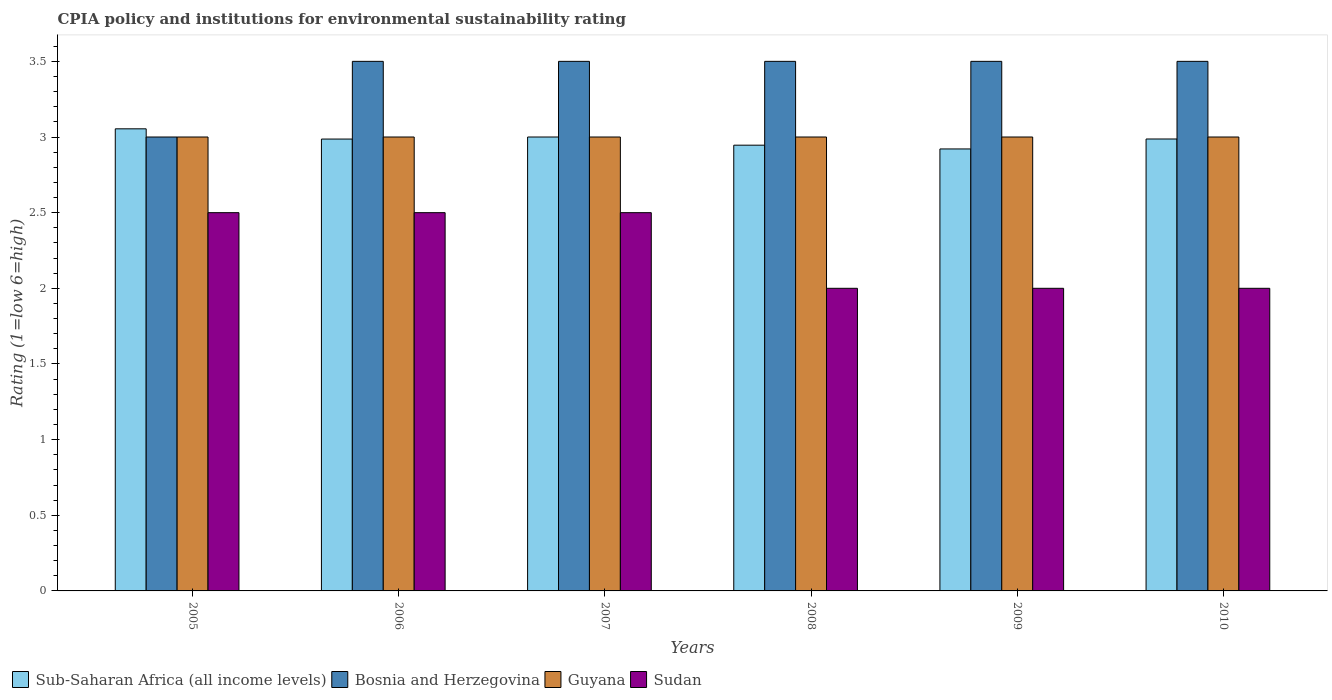How many groups of bars are there?
Make the answer very short. 6. Are the number of bars per tick equal to the number of legend labels?
Offer a terse response. Yes. Are the number of bars on each tick of the X-axis equal?
Your answer should be compact. Yes. How many bars are there on the 5th tick from the left?
Your answer should be compact. 4. How many bars are there on the 6th tick from the right?
Offer a terse response. 4. What is the CPIA rating in Sub-Saharan Africa (all income levels) in 2005?
Offer a terse response. 3.05. Across all years, what is the maximum CPIA rating in Sub-Saharan Africa (all income levels)?
Make the answer very short. 3.05. Across all years, what is the minimum CPIA rating in Bosnia and Herzegovina?
Provide a succinct answer. 3. What is the total CPIA rating in Guyana in the graph?
Offer a very short reply. 18. What is the difference between the CPIA rating in Guyana in 2009 and that in 2010?
Offer a very short reply. 0. What is the difference between the CPIA rating in Sub-Saharan Africa (all income levels) in 2008 and the CPIA rating in Sudan in 2010?
Provide a succinct answer. 0.95. What is the average CPIA rating in Sudan per year?
Make the answer very short. 2.25. In how many years, is the CPIA rating in Sudan greater than 0.8?
Give a very brief answer. 6. Is the CPIA rating in Guyana in 2005 less than that in 2007?
Provide a short and direct response. No. What is the difference between the highest and the lowest CPIA rating in Bosnia and Herzegovina?
Make the answer very short. 0.5. In how many years, is the CPIA rating in Sudan greater than the average CPIA rating in Sudan taken over all years?
Make the answer very short. 3. Is the sum of the CPIA rating in Sudan in 2008 and 2010 greater than the maximum CPIA rating in Guyana across all years?
Your response must be concise. Yes. Is it the case that in every year, the sum of the CPIA rating in Sub-Saharan Africa (all income levels) and CPIA rating in Guyana is greater than the sum of CPIA rating in Sudan and CPIA rating in Bosnia and Herzegovina?
Your answer should be very brief. Yes. What does the 1st bar from the left in 2007 represents?
Ensure brevity in your answer.  Sub-Saharan Africa (all income levels). What does the 1st bar from the right in 2006 represents?
Your response must be concise. Sudan. Are all the bars in the graph horizontal?
Give a very brief answer. No. How many years are there in the graph?
Give a very brief answer. 6. What is the difference between two consecutive major ticks on the Y-axis?
Ensure brevity in your answer.  0.5. Does the graph contain any zero values?
Your answer should be very brief. No. How many legend labels are there?
Your answer should be very brief. 4. What is the title of the graph?
Provide a short and direct response. CPIA policy and institutions for environmental sustainability rating. What is the label or title of the Y-axis?
Ensure brevity in your answer.  Rating (1=low 6=high). What is the Rating (1=low 6=high) in Sub-Saharan Africa (all income levels) in 2005?
Make the answer very short. 3.05. What is the Rating (1=low 6=high) of Bosnia and Herzegovina in 2005?
Offer a terse response. 3. What is the Rating (1=low 6=high) of Sudan in 2005?
Give a very brief answer. 2.5. What is the Rating (1=low 6=high) of Sub-Saharan Africa (all income levels) in 2006?
Provide a short and direct response. 2.99. What is the Rating (1=low 6=high) of Sudan in 2007?
Offer a terse response. 2.5. What is the Rating (1=low 6=high) in Sub-Saharan Africa (all income levels) in 2008?
Keep it short and to the point. 2.95. What is the Rating (1=low 6=high) of Bosnia and Herzegovina in 2008?
Ensure brevity in your answer.  3.5. What is the Rating (1=low 6=high) of Sudan in 2008?
Give a very brief answer. 2. What is the Rating (1=low 6=high) in Sub-Saharan Africa (all income levels) in 2009?
Your answer should be compact. 2.92. What is the Rating (1=low 6=high) in Bosnia and Herzegovina in 2009?
Your answer should be compact. 3.5. What is the Rating (1=low 6=high) of Guyana in 2009?
Provide a succinct answer. 3. What is the Rating (1=low 6=high) of Sudan in 2009?
Offer a very short reply. 2. What is the Rating (1=low 6=high) in Sub-Saharan Africa (all income levels) in 2010?
Provide a short and direct response. 2.99. What is the Rating (1=low 6=high) in Bosnia and Herzegovina in 2010?
Provide a short and direct response. 3.5. What is the Rating (1=low 6=high) of Sudan in 2010?
Your answer should be compact. 2. Across all years, what is the maximum Rating (1=low 6=high) of Sub-Saharan Africa (all income levels)?
Ensure brevity in your answer.  3.05. Across all years, what is the maximum Rating (1=low 6=high) in Bosnia and Herzegovina?
Provide a succinct answer. 3.5. Across all years, what is the maximum Rating (1=low 6=high) of Guyana?
Offer a terse response. 3. Across all years, what is the maximum Rating (1=low 6=high) of Sudan?
Make the answer very short. 2.5. Across all years, what is the minimum Rating (1=low 6=high) in Sub-Saharan Africa (all income levels)?
Offer a terse response. 2.92. Across all years, what is the minimum Rating (1=low 6=high) in Sudan?
Provide a short and direct response. 2. What is the total Rating (1=low 6=high) in Sub-Saharan Africa (all income levels) in the graph?
Offer a terse response. 17.89. What is the total Rating (1=low 6=high) of Bosnia and Herzegovina in the graph?
Provide a short and direct response. 20.5. What is the total Rating (1=low 6=high) of Sudan in the graph?
Ensure brevity in your answer.  13.5. What is the difference between the Rating (1=low 6=high) of Sub-Saharan Africa (all income levels) in 2005 and that in 2006?
Your response must be concise. 0.07. What is the difference between the Rating (1=low 6=high) of Bosnia and Herzegovina in 2005 and that in 2006?
Offer a terse response. -0.5. What is the difference between the Rating (1=low 6=high) in Guyana in 2005 and that in 2006?
Your answer should be very brief. 0. What is the difference between the Rating (1=low 6=high) in Sub-Saharan Africa (all income levels) in 2005 and that in 2007?
Your answer should be compact. 0.05. What is the difference between the Rating (1=low 6=high) of Bosnia and Herzegovina in 2005 and that in 2007?
Offer a very short reply. -0.5. What is the difference between the Rating (1=low 6=high) of Sudan in 2005 and that in 2007?
Your answer should be compact. 0. What is the difference between the Rating (1=low 6=high) of Sub-Saharan Africa (all income levels) in 2005 and that in 2008?
Your answer should be compact. 0.11. What is the difference between the Rating (1=low 6=high) in Guyana in 2005 and that in 2008?
Your answer should be compact. 0. What is the difference between the Rating (1=low 6=high) of Sudan in 2005 and that in 2008?
Your answer should be very brief. 0.5. What is the difference between the Rating (1=low 6=high) in Sub-Saharan Africa (all income levels) in 2005 and that in 2009?
Make the answer very short. 0.13. What is the difference between the Rating (1=low 6=high) of Bosnia and Herzegovina in 2005 and that in 2009?
Provide a succinct answer. -0.5. What is the difference between the Rating (1=low 6=high) of Sudan in 2005 and that in 2009?
Ensure brevity in your answer.  0.5. What is the difference between the Rating (1=low 6=high) in Sub-Saharan Africa (all income levels) in 2005 and that in 2010?
Your response must be concise. 0.07. What is the difference between the Rating (1=low 6=high) in Guyana in 2005 and that in 2010?
Provide a short and direct response. 0. What is the difference between the Rating (1=low 6=high) in Sub-Saharan Africa (all income levels) in 2006 and that in 2007?
Give a very brief answer. -0.01. What is the difference between the Rating (1=low 6=high) of Guyana in 2006 and that in 2007?
Your answer should be compact. 0. What is the difference between the Rating (1=low 6=high) in Sub-Saharan Africa (all income levels) in 2006 and that in 2008?
Make the answer very short. 0.04. What is the difference between the Rating (1=low 6=high) in Bosnia and Herzegovina in 2006 and that in 2008?
Offer a terse response. 0. What is the difference between the Rating (1=low 6=high) in Sudan in 2006 and that in 2008?
Offer a very short reply. 0.5. What is the difference between the Rating (1=low 6=high) of Sub-Saharan Africa (all income levels) in 2006 and that in 2009?
Give a very brief answer. 0.07. What is the difference between the Rating (1=low 6=high) in Sudan in 2006 and that in 2009?
Provide a short and direct response. 0.5. What is the difference between the Rating (1=low 6=high) in Sub-Saharan Africa (all income levels) in 2006 and that in 2010?
Offer a very short reply. -0. What is the difference between the Rating (1=low 6=high) in Bosnia and Herzegovina in 2006 and that in 2010?
Ensure brevity in your answer.  0. What is the difference between the Rating (1=low 6=high) of Guyana in 2006 and that in 2010?
Provide a succinct answer. 0. What is the difference between the Rating (1=low 6=high) of Sudan in 2006 and that in 2010?
Your answer should be very brief. 0.5. What is the difference between the Rating (1=low 6=high) of Sub-Saharan Africa (all income levels) in 2007 and that in 2008?
Give a very brief answer. 0.05. What is the difference between the Rating (1=low 6=high) of Guyana in 2007 and that in 2008?
Offer a terse response. 0. What is the difference between the Rating (1=low 6=high) in Sub-Saharan Africa (all income levels) in 2007 and that in 2009?
Offer a terse response. 0.08. What is the difference between the Rating (1=low 6=high) of Bosnia and Herzegovina in 2007 and that in 2009?
Provide a short and direct response. 0. What is the difference between the Rating (1=low 6=high) in Sudan in 2007 and that in 2009?
Your response must be concise. 0.5. What is the difference between the Rating (1=low 6=high) of Sub-Saharan Africa (all income levels) in 2007 and that in 2010?
Your answer should be compact. 0.01. What is the difference between the Rating (1=low 6=high) in Guyana in 2007 and that in 2010?
Your answer should be very brief. 0. What is the difference between the Rating (1=low 6=high) of Sudan in 2007 and that in 2010?
Your response must be concise. 0.5. What is the difference between the Rating (1=low 6=high) of Sub-Saharan Africa (all income levels) in 2008 and that in 2009?
Your answer should be very brief. 0.02. What is the difference between the Rating (1=low 6=high) of Sub-Saharan Africa (all income levels) in 2008 and that in 2010?
Make the answer very short. -0.04. What is the difference between the Rating (1=low 6=high) in Bosnia and Herzegovina in 2008 and that in 2010?
Offer a very short reply. 0. What is the difference between the Rating (1=low 6=high) of Guyana in 2008 and that in 2010?
Your answer should be very brief. 0. What is the difference between the Rating (1=low 6=high) of Sudan in 2008 and that in 2010?
Ensure brevity in your answer.  0. What is the difference between the Rating (1=low 6=high) of Sub-Saharan Africa (all income levels) in 2009 and that in 2010?
Offer a very short reply. -0.07. What is the difference between the Rating (1=low 6=high) of Sudan in 2009 and that in 2010?
Offer a very short reply. 0. What is the difference between the Rating (1=low 6=high) in Sub-Saharan Africa (all income levels) in 2005 and the Rating (1=low 6=high) in Bosnia and Herzegovina in 2006?
Keep it short and to the point. -0.45. What is the difference between the Rating (1=low 6=high) in Sub-Saharan Africa (all income levels) in 2005 and the Rating (1=low 6=high) in Guyana in 2006?
Offer a terse response. 0.05. What is the difference between the Rating (1=low 6=high) in Sub-Saharan Africa (all income levels) in 2005 and the Rating (1=low 6=high) in Sudan in 2006?
Offer a very short reply. 0.55. What is the difference between the Rating (1=low 6=high) in Bosnia and Herzegovina in 2005 and the Rating (1=low 6=high) in Sudan in 2006?
Give a very brief answer. 0.5. What is the difference between the Rating (1=low 6=high) of Sub-Saharan Africa (all income levels) in 2005 and the Rating (1=low 6=high) of Bosnia and Herzegovina in 2007?
Your answer should be very brief. -0.45. What is the difference between the Rating (1=low 6=high) in Sub-Saharan Africa (all income levels) in 2005 and the Rating (1=low 6=high) in Guyana in 2007?
Keep it short and to the point. 0.05. What is the difference between the Rating (1=low 6=high) in Sub-Saharan Africa (all income levels) in 2005 and the Rating (1=low 6=high) in Sudan in 2007?
Give a very brief answer. 0.55. What is the difference between the Rating (1=low 6=high) in Bosnia and Herzegovina in 2005 and the Rating (1=low 6=high) in Guyana in 2007?
Ensure brevity in your answer.  0. What is the difference between the Rating (1=low 6=high) in Bosnia and Herzegovina in 2005 and the Rating (1=low 6=high) in Sudan in 2007?
Give a very brief answer. 0.5. What is the difference between the Rating (1=low 6=high) in Guyana in 2005 and the Rating (1=low 6=high) in Sudan in 2007?
Keep it short and to the point. 0.5. What is the difference between the Rating (1=low 6=high) in Sub-Saharan Africa (all income levels) in 2005 and the Rating (1=low 6=high) in Bosnia and Herzegovina in 2008?
Ensure brevity in your answer.  -0.45. What is the difference between the Rating (1=low 6=high) of Sub-Saharan Africa (all income levels) in 2005 and the Rating (1=low 6=high) of Guyana in 2008?
Provide a short and direct response. 0.05. What is the difference between the Rating (1=low 6=high) in Sub-Saharan Africa (all income levels) in 2005 and the Rating (1=low 6=high) in Sudan in 2008?
Ensure brevity in your answer.  1.05. What is the difference between the Rating (1=low 6=high) in Bosnia and Herzegovina in 2005 and the Rating (1=low 6=high) in Guyana in 2008?
Your response must be concise. 0. What is the difference between the Rating (1=low 6=high) in Sub-Saharan Africa (all income levels) in 2005 and the Rating (1=low 6=high) in Bosnia and Herzegovina in 2009?
Provide a succinct answer. -0.45. What is the difference between the Rating (1=low 6=high) in Sub-Saharan Africa (all income levels) in 2005 and the Rating (1=low 6=high) in Guyana in 2009?
Provide a short and direct response. 0.05. What is the difference between the Rating (1=low 6=high) of Sub-Saharan Africa (all income levels) in 2005 and the Rating (1=low 6=high) of Sudan in 2009?
Offer a very short reply. 1.05. What is the difference between the Rating (1=low 6=high) in Bosnia and Herzegovina in 2005 and the Rating (1=low 6=high) in Guyana in 2009?
Your answer should be very brief. 0. What is the difference between the Rating (1=low 6=high) of Sub-Saharan Africa (all income levels) in 2005 and the Rating (1=low 6=high) of Bosnia and Herzegovina in 2010?
Ensure brevity in your answer.  -0.45. What is the difference between the Rating (1=low 6=high) of Sub-Saharan Africa (all income levels) in 2005 and the Rating (1=low 6=high) of Guyana in 2010?
Your response must be concise. 0.05. What is the difference between the Rating (1=low 6=high) of Sub-Saharan Africa (all income levels) in 2005 and the Rating (1=low 6=high) of Sudan in 2010?
Ensure brevity in your answer.  1.05. What is the difference between the Rating (1=low 6=high) of Bosnia and Herzegovina in 2005 and the Rating (1=low 6=high) of Sudan in 2010?
Provide a short and direct response. 1. What is the difference between the Rating (1=low 6=high) in Guyana in 2005 and the Rating (1=low 6=high) in Sudan in 2010?
Keep it short and to the point. 1. What is the difference between the Rating (1=low 6=high) of Sub-Saharan Africa (all income levels) in 2006 and the Rating (1=low 6=high) of Bosnia and Herzegovina in 2007?
Provide a succinct answer. -0.51. What is the difference between the Rating (1=low 6=high) of Sub-Saharan Africa (all income levels) in 2006 and the Rating (1=low 6=high) of Guyana in 2007?
Your answer should be very brief. -0.01. What is the difference between the Rating (1=low 6=high) of Sub-Saharan Africa (all income levels) in 2006 and the Rating (1=low 6=high) of Sudan in 2007?
Offer a very short reply. 0.49. What is the difference between the Rating (1=low 6=high) in Bosnia and Herzegovina in 2006 and the Rating (1=low 6=high) in Guyana in 2007?
Your response must be concise. 0.5. What is the difference between the Rating (1=low 6=high) of Bosnia and Herzegovina in 2006 and the Rating (1=low 6=high) of Sudan in 2007?
Offer a terse response. 1. What is the difference between the Rating (1=low 6=high) of Sub-Saharan Africa (all income levels) in 2006 and the Rating (1=low 6=high) of Bosnia and Herzegovina in 2008?
Provide a succinct answer. -0.51. What is the difference between the Rating (1=low 6=high) of Sub-Saharan Africa (all income levels) in 2006 and the Rating (1=low 6=high) of Guyana in 2008?
Give a very brief answer. -0.01. What is the difference between the Rating (1=low 6=high) in Sub-Saharan Africa (all income levels) in 2006 and the Rating (1=low 6=high) in Sudan in 2008?
Offer a very short reply. 0.99. What is the difference between the Rating (1=low 6=high) of Guyana in 2006 and the Rating (1=low 6=high) of Sudan in 2008?
Offer a very short reply. 1. What is the difference between the Rating (1=low 6=high) in Sub-Saharan Africa (all income levels) in 2006 and the Rating (1=low 6=high) in Bosnia and Herzegovina in 2009?
Your answer should be compact. -0.51. What is the difference between the Rating (1=low 6=high) of Sub-Saharan Africa (all income levels) in 2006 and the Rating (1=low 6=high) of Guyana in 2009?
Provide a succinct answer. -0.01. What is the difference between the Rating (1=low 6=high) in Sub-Saharan Africa (all income levels) in 2006 and the Rating (1=low 6=high) in Sudan in 2009?
Your answer should be very brief. 0.99. What is the difference between the Rating (1=low 6=high) of Bosnia and Herzegovina in 2006 and the Rating (1=low 6=high) of Guyana in 2009?
Give a very brief answer. 0.5. What is the difference between the Rating (1=low 6=high) of Bosnia and Herzegovina in 2006 and the Rating (1=low 6=high) of Sudan in 2009?
Give a very brief answer. 1.5. What is the difference between the Rating (1=low 6=high) in Sub-Saharan Africa (all income levels) in 2006 and the Rating (1=low 6=high) in Bosnia and Herzegovina in 2010?
Keep it short and to the point. -0.51. What is the difference between the Rating (1=low 6=high) in Sub-Saharan Africa (all income levels) in 2006 and the Rating (1=low 6=high) in Guyana in 2010?
Offer a very short reply. -0.01. What is the difference between the Rating (1=low 6=high) in Sub-Saharan Africa (all income levels) in 2006 and the Rating (1=low 6=high) in Sudan in 2010?
Your answer should be very brief. 0.99. What is the difference between the Rating (1=low 6=high) of Bosnia and Herzegovina in 2006 and the Rating (1=low 6=high) of Guyana in 2010?
Provide a short and direct response. 0.5. What is the difference between the Rating (1=low 6=high) of Sub-Saharan Africa (all income levels) in 2007 and the Rating (1=low 6=high) of Guyana in 2008?
Offer a very short reply. 0. What is the difference between the Rating (1=low 6=high) of Sub-Saharan Africa (all income levels) in 2007 and the Rating (1=low 6=high) of Sudan in 2008?
Your response must be concise. 1. What is the difference between the Rating (1=low 6=high) of Bosnia and Herzegovina in 2007 and the Rating (1=low 6=high) of Guyana in 2008?
Your response must be concise. 0.5. What is the difference between the Rating (1=low 6=high) in Guyana in 2007 and the Rating (1=low 6=high) in Sudan in 2008?
Provide a succinct answer. 1. What is the difference between the Rating (1=low 6=high) in Sub-Saharan Africa (all income levels) in 2007 and the Rating (1=low 6=high) in Bosnia and Herzegovina in 2009?
Your answer should be compact. -0.5. What is the difference between the Rating (1=low 6=high) of Sub-Saharan Africa (all income levels) in 2007 and the Rating (1=low 6=high) of Guyana in 2009?
Ensure brevity in your answer.  0. What is the difference between the Rating (1=low 6=high) in Bosnia and Herzegovina in 2007 and the Rating (1=low 6=high) in Guyana in 2009?
Your response must be concise. 0.5. What is the difference between the Rating (1=low 6=high) of Guyana in 2007 and the Rating (1=low 6=high) of Sudan in 2009?
Provide a succinct answer. 1. What is the difference between the Rating (1=low 6=high) in Sub-Saharan Africa (all income levels) in 2007 and the Rating (1=low 6=high) in Bosnia and Herzegovina in 2010?
Keep it short and to the point. -0.5. What is the difference between the Rating (1=low 6=high) in Sub-Saharan Africa (all income levels) in 2007 and the Rating (1=low 6=high) in Guyana in 2010?
Ensure brevity in your answer.  0. What is the difference between the Rating (1=low 6=high) of Sub-Saharan Africa (all income levels) in 2007 and the Rating (1=low 6=high) of Sudan in 2010?
Your answer should be very brief. 1. What is the difference between the Rating (1=low 6=high) of Sub-Saharan Africa (all income levels) in 2008 and the Rating (1=low 6=high) of Bosnia and Herzegovina in 2009?
Provide a succinct answer. -0.55. What is the difference between the Rating (1=low 6=high) of Sub-Saharan Africa (all income levels) in 2008 and the Rating (1=low 6=high) of Guyana in 2009?
Provide a succinct answer. -0.05. What is the difference between the Rating (1=low 6=high) in Sub-Saharan Africa (all income levels) in 2008 and the Rating (1=low 6=high) in Sudan in 2009?
Offer a very short reply. 0.95. What is the difference between the Rating (1=low 6=high) in Guyana in 2008 and the Rating (1=low 6=high) in Sudan in 2009?
Make the answer very short. 1. What is the difference between the Rating (1=low 6=high) in Sub-Saharan Africa (all income levels) in 2008 and the Rating (1=low 6=high) in Bosnia and Herzegovina in 2010?
Provide a short and direct response. -0.55. What is the difference between the Rating (1=low 6=high) in Sub-Saharan Africa (all income levels) in 2008 and the Rating (1=low 6=high) in Guyana in 2010?
Offer a very short reply. -0.05. What is the difference between the Rating (1=low 6=high) in Sub-Saharan Africa (all income levels) in 2008 and the Rating (1=low 6=high) in Sudan in 2010?
Offer a very short reply. 0.95. What is the difference between the Rating (1=low 6=high) of Bosnia and Herzegovina in 2008 and the Rating (1=low 6=high) of Guyana in 2010?
Ensure brevity in your answer.  0.5. What is the difference between the Rating (1=low 6=high) of Sub-Saharan Africa (all income levels) in 2009 and the Rating (1=low 6=high) of Bosnia and Herzegovina in 2010?
Your answer should be very brief. -0.58. What is the difference between the Rating (1=low 6=high) of Sub-Saharan Africa (all income levels) in 2009 and the Rating (1=low 6=high) of Guyana in 2010?
Offer a terse response. -0.08. What is the difference between the Rating (1=low 6=high) in Sub-Saharan Africa (all income levels) in 2009 and the Rating (1=low 6=high) in Sudan in 2010?
Provide a short and direct response. 0.92. What is the average Rating (1=low 6=high) in Sub-Saharan Africa (all income levels) per year?
Offer a terse response. 2.98. What is the average Rating (1=low 6=high) in Bosnia and Herzegovina per year?
Keep it short and to the point. 3.42. What is the average Rating (1=low 6=high) in Sudan per year?
Make the answer very short. 2.25. In the year 2005, what is the difference between the Rating (1=low 6=high) in Sub-Saharan Africa (all income levels) and Rating (1=low 6=high) in Bosnia and Herzegovina?
Your response must be concise. 0.05. In the year 2005, what is the difference between the Rating (1=low 6=high) of Sub-Saharan Africa (all income levels) and Rating (1=low 6=high) of Guyana?
Offer a very short reply. 0.05. In the year 2005, what is the difference between the Rating (1=low 6=high) of Sub-Saharan Africa (all income levels) and Rating (1=low 6=high) of Sudan?
Provide a short and direct response. 0.55. In the year 2005, what is the difference between the Rating (1=low 6=high) in Guyana and Rating (1=low 6=high) in Sudan?
Offer a terse response. 0.5. In the year 2006, what is the difference between the Rating (1=low 6=high) in Sub-Saharan Africa (all income levels) and Rating (1=low 6=high) in Bosnia and Herzegovina?
Offer a very short reply. -0.51. In the year 2006, what is the difference between the Rating (1=low 6=high) of Sub-Saharan Africa (all income levels) and Rating (1=low 6=high) of Guyana?
Ensure brevity in your answer.  -0.01. In the year 2006, what is the difference between the Rating (1=low 6=high) of Sub-Saharan Africa (all income levels) and Rating (1=low 6=high) of Sudan?
Your answer should be compact. 0.49. In the year 2006, what is the difference between the Rating (1=low 6=high) in Bosnia and Herzegovina and Rating (1=low 6=high) in Sudan?
Make the answer very short. 1. In the year 2006, what is the difference between the Rating (1=low 6=high) in Guyana and Rating (1=low 6=high) in Sudan?
Provide a succinct answer. 0.5. In the year 2007, what is the difference between the Rating (1=low 6=high) of Sub-Saharan Africa (all income levels) and Rating (1=low 6=high) of Bosnia and Herzegovina?
Offer a terse response. -0.5. In the year 2007, what is the difference between the Rating (1=low 6=high) in Bosnia and Herzegovina and Rating (1=low 6=high) in Guyana?
Provide a succinct answer. 0.5. In the year 2007, what is the difference between the Rating (1=low 6=high) of Guyana and Rating (1=low 6=high) of Sudan?
Ensure brevity in your answer.  0.5. In the year 2008, what is the difference between the Rating (1=low 6=high) of Sub-Saharan Africa (all income levels) and Rating (1=low 6=high) of Bosnia and Herzegovina?
Your answer should be very brief. -0.55. In the year 2008, what is the difference between the Rating (1=low 6=high) in Sub-Saharan Africa (all income levels) and Rating (1=low 6=high) in Guyana?
Offer a very short reply. -0.05. In the year 2008, what is the difference between the Rating (1=low 6=high) of Sub-Saharan Africa (all income levels) and Rating (1=low 6=high) of Sudan?
Provide a short and direct response. 0.95. In the year 2008, what is the difference between the Rating (1=low 6=high) in Bosnia and Herzegovina and Rating (1=low 6=high) in Guyana?
Provide a succinct answer. 0.5. In the year 2008, what is the difference between the Rating (1=low 6=high) in Bosnia and Herzegovina and Rating (1=low 6=high) in Sudan?
Make the answer very short. 1.5. In the year 2009, what is the difference between the Rating (1=low 6=high) of Sub-Saharan Africa (all income levels) and Rating (1=low 6=high) of Bosnia and Herzegovina?
Your answer should be compact. -0.58. In the year 2009, what is the difference between the Rating (1=low 6=high) in Sub-Saharan Africa (all income levels) and Rating (1=low 6=high) in Guyana?
Your answer should be compact. -0.08. In the year 2009, what is the difference between the Rating (1=low 6=high) of Sub-Saharan Africa (all income levels) and Rating (1=low 6=high) of Sudan?
Provide a short and direct response. 0.92. In the year 2009, what is the difference between the Rating (1=low 6=high) of Bosnia and Herzegovina and Rating (1=low 6=high) of Guyana?
Your answer should be compact. 0.5. In the year 2010, what is the difference between the Rating (1=low 6=high) of Sub-Saharan Africa (all income levels) and Rating (1=low 6=high) of Bosnia and Herzegovina?
Offer a terse response. -0.51. In the year 2010, what is the difference between the Rating (1=low 6=high) in Sub-Saharan Africa (all income levels) and Rating (1=low 6=high) in Guyana?
Your response must be concise. -0.01. In the year 2010, what is the difference between the Rating (1=low 6=high) of Guyana and Rating (1=low 6=high) of Sudan?
Offer a terse response. 1. What is the ratio of the Rating (1=low 6=high) in Sub-Saharan Africa (all income levels) in 2005 to that in 2006?
Offer a terse response. 1.02. What is the ratio of the Rating (1=low 6=high) of Sub-Saharan Africa (all income levels) in 2005 to that in 2007?
Your response must be concise. 1.02. What is the ratio of the Rating (1=low 6=high) of Sudan in 2005 to that in 2007?
Offer a terse response. 1. What is the ratio of the Rating (1=low 6=high) of Sub-Saharan Africa (all income levels) in 2005 to that in 2008?
Offer a very short reply. 1.04. What is the ratio of the Rating (1=low 6=high) of Sub-Saharan Africa (all income levels) in 2005 to that in 2009?
Your response must be concise. 1.05. What is the ratio of the Rating (1=low 6=high) of Guyana in 2005 to that in 2009?
Keep it short and to the point. 1. What is the ratio of the Rating (1=low 6=high) in Sub-Saharan Africa (all income levels) in 2005 to that in 2010?
Ensure brevity in your answer.  1.02. What is the ratio of the Rating (1=low 6=high) of Guyana in 2005 to that in 2010?
Your response must be concise. 1. What is the ratio of the Rating (1=low 6=high) of Sudan in 2005 to that in 2010?
Make the answer very short. 1.25. What is the ratio of the Rating (1=low 6=high) in Sub-Saharan Africa (all income levels) in 2006 to that in 2007?
Offer a terse response. 1. What is the ratio of the Rating (1=low 6=high) of Sudan in 2006 to that in 2007?
Keep it short and to the point. 1. What is the ratio of the Rating (1=low 6=high) of Sub-Saharan Africa (all income levels) in 2006 to that in 2008?
Give a very brief answer. 1.01. What is the ratio of the Rating (1=low 6=high) in Guyana in 2006 to that in 2008?
Your answer should be very brief. 1. What is the ratio of the Rating (1=low 6=high) in Sudan in 2006 to that in 2008?
Offer a very short reply. 1.25. What is the ratio of the Rating (1=low 6=high) in Sub-Saharan Africa (all income levels) in 2006 to that in 2009?
Provide a succinct answer. 1.02. What is the ratio of the Rating (1=low 6=high) of Bosnia and Herzegovina in 2006 to that in 2009?
Ensure brevity in your answer.  1. What is the ratio of the Rating (1=low 6=high) of Sub-Saharan Africa (all income levels) in 2006 to that in 2010?
Provide a succinct answer. 1. What is the ratio of the Rating (1=low 6=high) in Bosnia and Herzegovina in 2006 to that in 2010?
Your response must be concise. 1. What is the ratio of the Rating (1=low 6=high) in Guyana in 2006 to that in 2010?
Make the answer very short. 1. What is the ratio of the Rating (1=low 6=high) of Sudan in 2006 to that in 2010?
Keep it short and to the point. 1.25. What is the ratio of the Rating (1=low 6=high) in Sub-Saharan Africa (all income levels) in 2007 to that in 2008?
Provide a short and direct response. 1.02. What is the ratio of the Rating (1=low 6=high) of Guyana in 2007 to that in 2008?
Provide a short and direct response. 1. What is the ratio of the Rating (1=low 6=high) in Sudan in 2007 to that in 2008?
Your answer should be very brief. 1.25. What is the ratio of the Rating (1=low 6=high) in Guyana in 2007 to that in 2009?
Your answer should be compact. 1. What is the ratio of the Rating (1=low 6=high) of Sudan in 2007 to that in 2009?
Provide a succinct answer. 1.25. What is the ratio of the Rating (1=low 6=high) in Guyana in 2007 to that in 2010?
Provide a succinct answer. 1. What is the ratio of the Rating (1=low 6=high) in Sudan in 2007 to that in 2010?
Offer a very short reply. 1.25. What is the ratio of the Rating (1=low 6=high) in Sub-Saharan Africa (all income levels) in 2008 to that in 2009?
Your response must be concise. 1.01. What is the ratio of the Rating (1=low 6=high) in Bosnia and Herzegovina in 2008 to that in 2009?
Your response must be concise. 1. What is the ratio of the Rating (1=low 6=high) in Sub-Saharan Africa (all income levels) in 2008 to that in 2010?
Keep it short and to the point. 0.99. What is the ratio of the Rating (1=low 6=high) of Bosnia and Herzegovina in 2008 to that in 2010?
Your response must be concise. 1. What is the ratio of the Rating (1=low 6=high) of Sudan in 2008 to that in 2010?
Give a very brief answer. 1. What is the ratio of the Rating (1=low 6=high) in Sub-Saharan Africa (all income levels) in 2009 to that in 2010?
Give a very brief answer. 0.98. What is the ratio of the Rating (1=low 6=high) in Guyana in 2009 to that in 2010?
Give a very brief answer. 1. What is the ratio of the Rating (1=low 6=high) in Sudan in 2009 to that in 2010?
Offer a very short reply. 1. What is the difference between the highest and the second highest Rating (1=low 6=high) in Sub-Saharan Africa (all income levels)?
Ensure brevity in your answer.  0.05. What is the difference between the highest and the second highest Rating (1=low 6=high) of Bosnia and Herzegovina?
Your answer should be very brief. 0. What is the difference between the highest and the second highest Rating (1=low 6=high) in Guyana?
Give a very brief answer. 0. What is the difference between the highest and the lowest Rating (1=low 6=high) in Sub-Saharan Africa (all income levels)?
Provide a short and direct response. 0.13. What is the difference between the highest and the lowest Rating (1=low 6=high) of Bosnia and Herzegovina?
Provide a short and direct response. 0.5. What is the difference between the highest and the lowest Rating (1=low 6=high) in Guyana?
Your answer should be compact. 0. What is the difference between the highest and the lowest Rating (1=low 6=high) of Sudan?
Give a very brief answer. 0.5. 